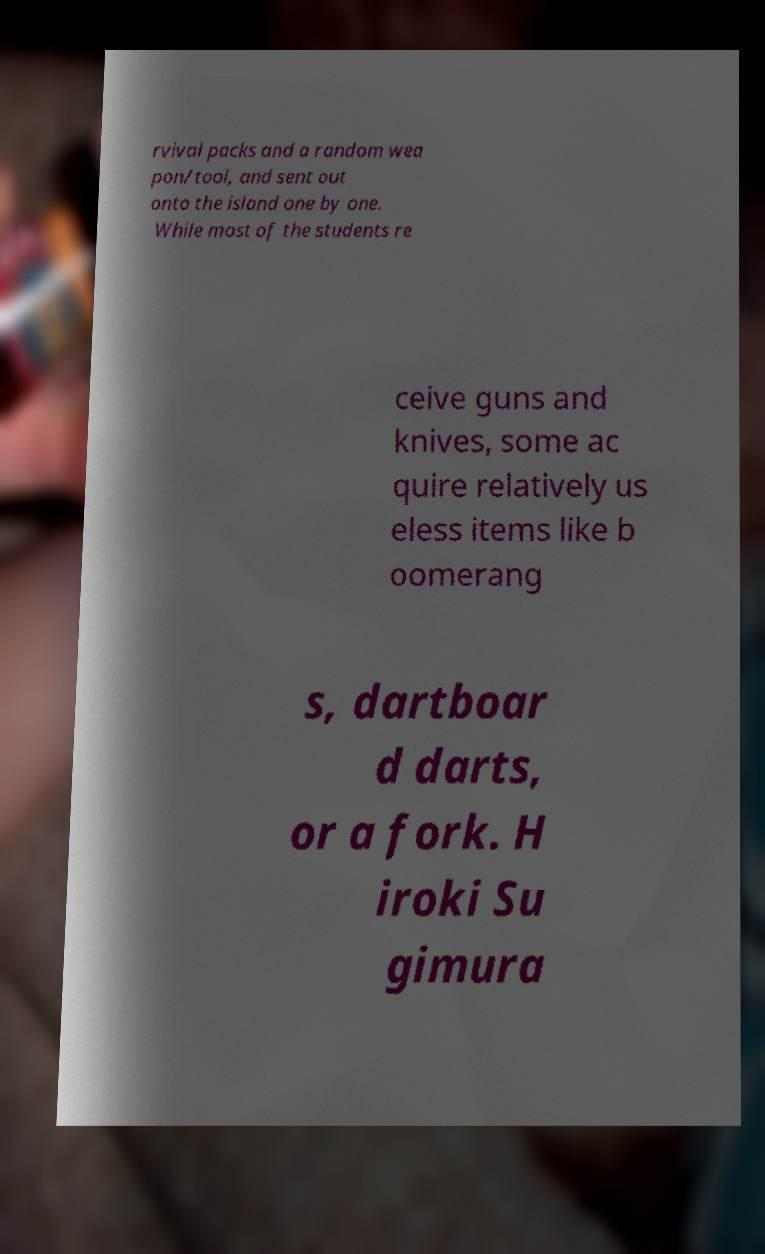Please identify and transcribe the text found in this image. rvival packs and a random wea pon/tool, and sent out onto the island one by one. While most of the students re ceive guns and knives, some ac quire relatively us eless items like b oomerang s, dartboar d darts, or a fork. H iroki Su gimura 